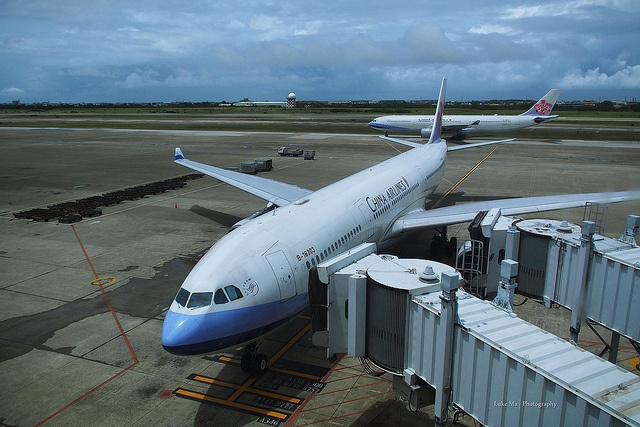Describe the objects in this image and their specific colors. I can see airplane in gray, lightblue, and black tones, airplane in gray, black, and lightblue tones, and truck in gray, black, purple, and darkgray tones in this image. 